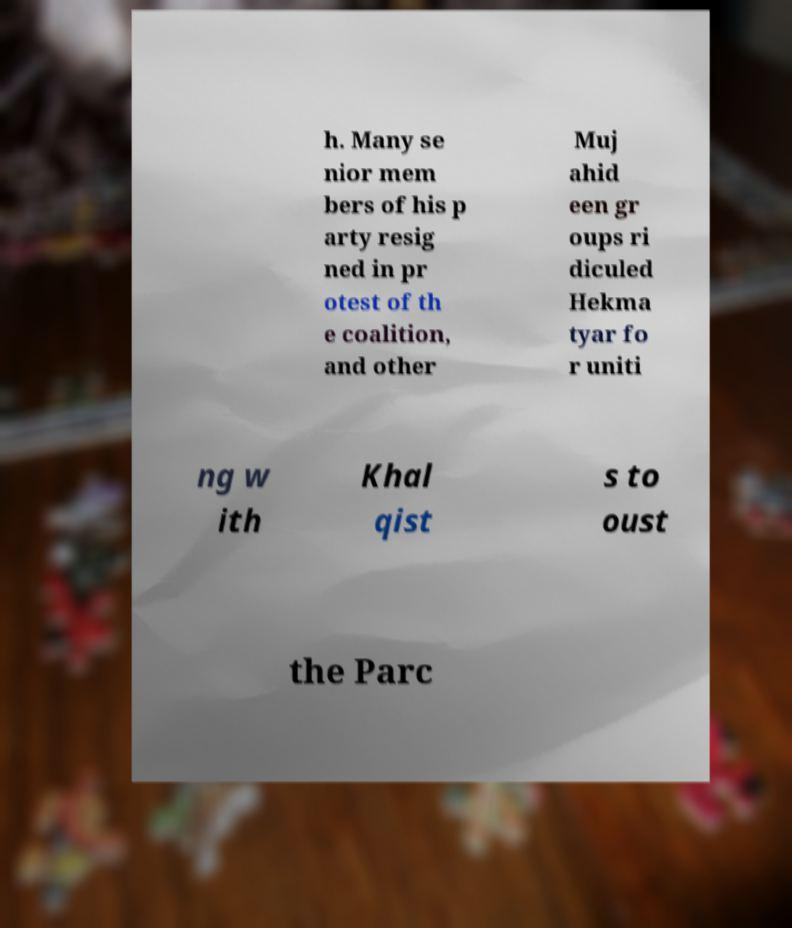Can you read and provide the text displayed in the image?This photo seems to have some interesting text. Can you extract and type it out for me? h. Many se nior mem bers of his p arty resig ned in pr otest of th e coalition, and other Muj ahid een gr oups ri diculed Hekma tyar fo r uniti ng w ith Khal qist s to oust the Parc 